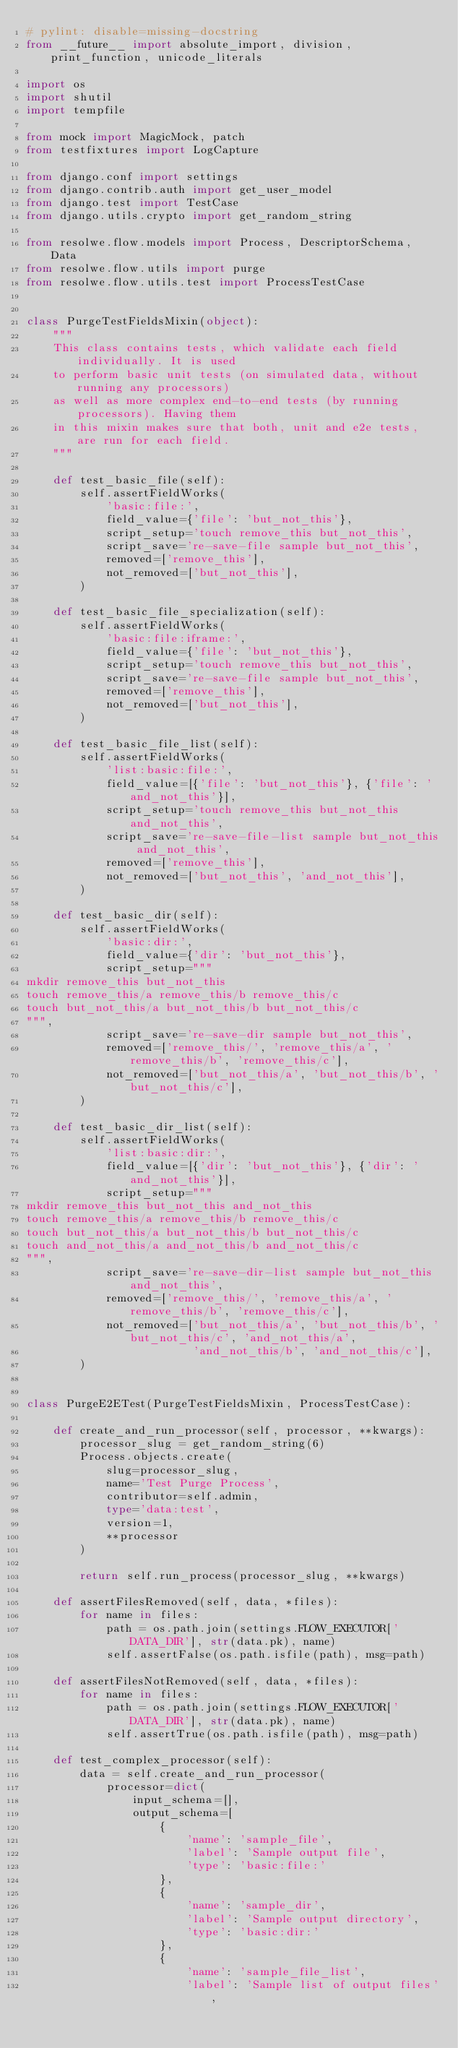<code> <loc_0><loc_0><loc_500><loc_500><_Python_># pylint: disable=missing-docstring
from __future__ import absolute_import, division, print_function, unicode_literals

import os
import shutil
import tempfile

from mock import MagicMock, patch
from testfixtures import LogCapture

from django.conf import settings
from django.contrib.auth import get_user_model
from django.test import TestCase
from django.utils.crypto import get_random_string

from resolwe.flow.models import Process, DescriptorSchema, Data
from resolwe.flow.utils import purge
from resolwe.flow.utils.test import ProcessTestCase


class PurgeTestFieldsMixin(object):
    """
    This class contains tests, which validate each field individually. It is used
    to perform basic unit tests (on simulated data, without running any processors)
    as well as more complex end-to-end tests (by running processors). Having them
    in this mixin makes sure that both, unit and e2e tests, are run for each field.
    """

    def test_basic_file(self):
        self.assertFieldWorks(
            'basic:file:',
            field_value={'file': 'but_not_this'},
            script_setup='touch remove_this but_not_this',
            script_save='re-save-file sample but_not_this',
            removed=['remove_this'],
            not_removed=['but_not_this'],
        )

    def test_basic_file_specialization(self):
        self.assertFieldWorks(
            'basic:file:iframe:',
            field_value={'file': 'but_not_this'},
            script_setup='touch remove_this but_not_this',
            script_save='re-save-file sample but_not_this',
            removed=['remove_this'],
            not_removed=['but_not_this'],
        )

    def test_basic_file_list(self):
        self.assertFieldWorks(
            'list:basic:file:',
            field_value=[{'file': 'but_not_this'}, {'file': 'and_not_this'}],
            script_setup='touch remove_this but_not_this and_not_this',
            script_save='re-save-file-list sample but_not_this and_not_this',
            removed=['remove_this'],
            not_removed=['but_not_this', 'and_not_this'],
        )

    def test_basic_dir(self):
        self.assertFieldWorks(
            'basic:dir:',
            field_value={'dir': 'but_not_this'},
            script_setup="""
mkdir remove_this but_not_this
touch remove_this/a remove_this/b remove_this/c
touch but_not_this/a but_not_this/b but_not_this/c
""",
            script_save='re-save-dir sample but_not_this',
            removed=['remove_this/', 'remove_this/a', 'remove_this/b', 'remove_this/c'],
            not_removed=['but_not_this/a', 'but_not_this/b', 'but_not_this/c'],
        )

    def test_basic_dir_list(self):
        self.assertFieldWorks(
            'list:basic:dir:',
            field_value=[{'dir': 'but_not_this'}, {'dir': 'and_not_this'}],
            script_setup="""
mkdir remove_this but_not_this and_not_this
touch remove_this/a remove_this/b remove_this/c
touch but_not_this/a but_not_this/b but_not_this/c
touch and_not_this/a and_not_this/b and_not_this/c
""",
            script_save='re-save-dir-list sample but_not_this and_not_this',
            removed=['remove_this/', 'remove_this/a', 'remove_this/b', 'remove_this/c'],
            not_removed=['but_not_this/a', 'but_not_this/b', 'but_not_this/c', 'and_not_this/a',
                         'and_not_this/b', 'and_not_this/c'],
        )


class PurgeE2ETest(PurgeTestFieldsMixin, ProcessTestCase):

    def create_and_run_processor(self, processor, **kwargs):
        processor_slug = get_random_string(6)
        Process.objects.create(
            slug=processor_slug,
            name='Test Purge Process',
            contributor=self.admin,
            type='data:test',
            version=1,
            **processor
        )

        return self.run_process(processor_slug, **kwargs)

    def assertFilesRemoved(self, data, *files):
        for name in files:
            path = os.path.join(settings.FLOW_EXECUTOR['DATA_DIR'], str(data.pk), name)
            self.assertFalse(os.path.isfile(path), msg=path)

    def assertFilesNotRemoved(self, data, *files):
        for name in files:
            path = os.path.join(settings.FLOW_EXECUTOR['DATA_DIR'], str(data.pk), name)
            self.assertTrue(os.path.isfile(path), msg=path)

    def test_complex_processor(self):
        data = self.create_and_run_processor(
            processor=dict(
                input_schema=[],
                output_schema=[
                    {
                        'name': 'sample_file',
                        'label': 'Sample output file',
                        'type': 'basic:file:'
                    },
                    {
                        'name': 'sample_dir',
                        'label': 'Sample output directory',
                        'type': 'basic:dir:'
                    },
                    {
                        'name': 'sample_file_list',
                        'label': 'Sample list of output files',</code> 